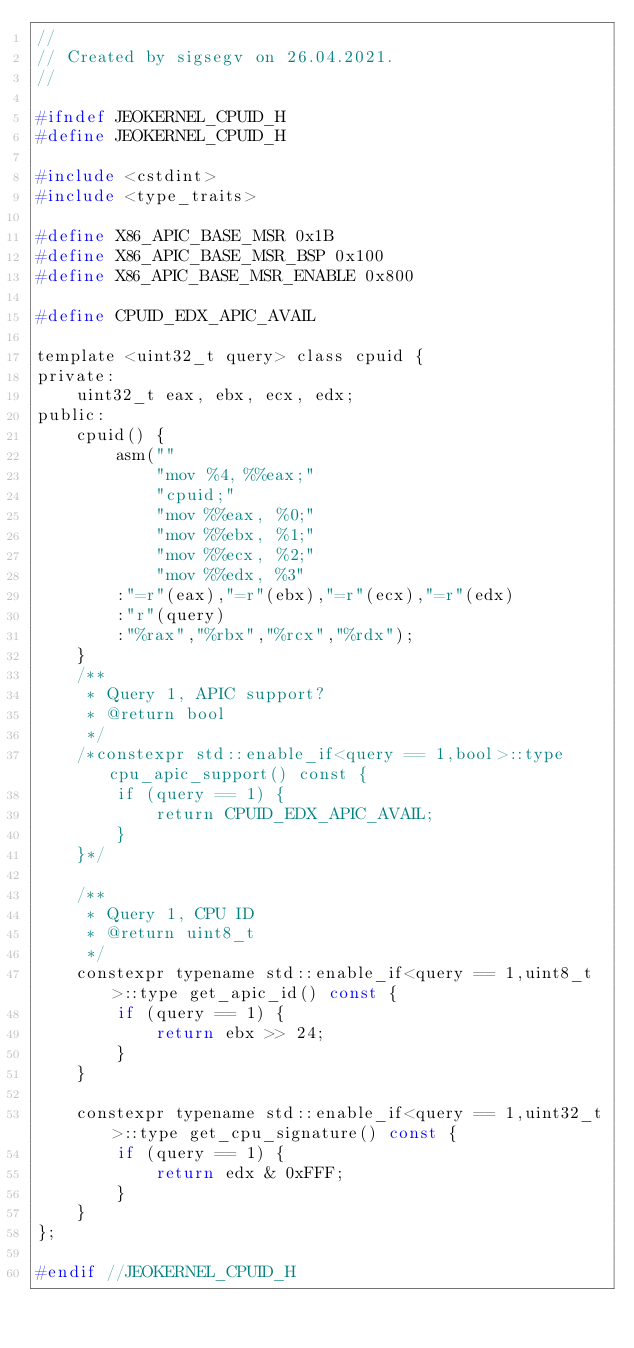<code> <loc_0><loc_0><loc_500><loc_500><_C_>//
// Created by sigsegv on 26.04.2021.
//

#ifndef JEOKERNEL_CPUID_H
#define JEOKERNEL_CPUID_H

#include <cstdint>
#include <type_traits>

#define X86_APIC_BASE_MSR 0x1B
#define X86_APIC_BASE_MSR_BSP 0x100
#define X86_APIC_BASE_MSR_ENABLE 0x800

#define CPUID_EDX_APIC_AVAIL

template <uint32_t query> class cpuid {
private:
    uint32_t eax, ebx, ecx, edx;
public:
    cpuid() {
        asm(""
            "mov %4, %%eax;"
            "cpuid;"
            "mov %%eax, %0;"
            "mov %%ebx, %1;"
            "mov %%ecx, %2;"
            "mov %%edx, %3"
        :"=r"(eax),"=r"(ebx),"=r"(ecx),"=r"(edx)
        :"r"(query)
        :"%rax","%rbx","%rcx","%rdx");
    }
    /**
     * Query 1, APIC support?
     * @return bool
     */
    /*constexpr std::enable_if<query == 1,bool>::type cpu_apic_support() const {
        if (query == 1) {
            return CPUID_EDX_APIC_AVAIL;
        }
    }*/

    /**
     * Query 1, CPU ID
     * @return uint8_t
     */
    constexpr typename std::enable_if<query == 1,uint8_t>::type get_apic_id() const {
        if (query == 1) {
            return ebx >> 24;
        }
    }

    constexpr typename std::enable_if<query == 1,uint32_t>::type get_cpu_signature() const {
        if (query == 1) {
            return edx & 0xFFF;
        }
    }
};

#endif //JEOKERNEL_CPUID_H
</code> 